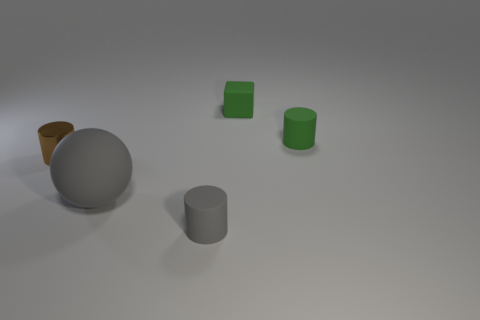Subtract all tiny matte cylinders. How many cylinders are left? 1 Add 3 small rubber objects. How many objects exist? 8 Subtract 1 spheres. How many spheres are left? 0 Subtract all green cylinders. How many cylinders are left? 2 Subtract all blocks. How many objects are left? 4 Subtract 0 red balls. How many objects are left? 5 Subtract all gray cylinders. Subtract all purple blocks. How many cylinders are left? 2 Subtract all tiny yellow metal cylinders. Subtract all cylinders. How many objects are left? 2 Add 5 small cylinders. How many small cylinders are left? 8 Add 3 small green matte objects. How many small green matte objects exist? 5 